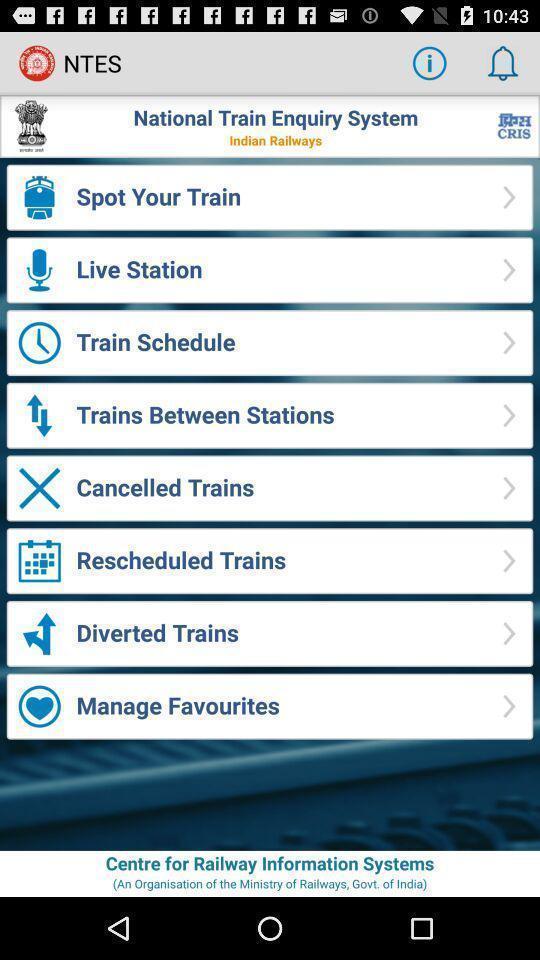What can you discern from this picture? Page with menu for a public transportation services app. 